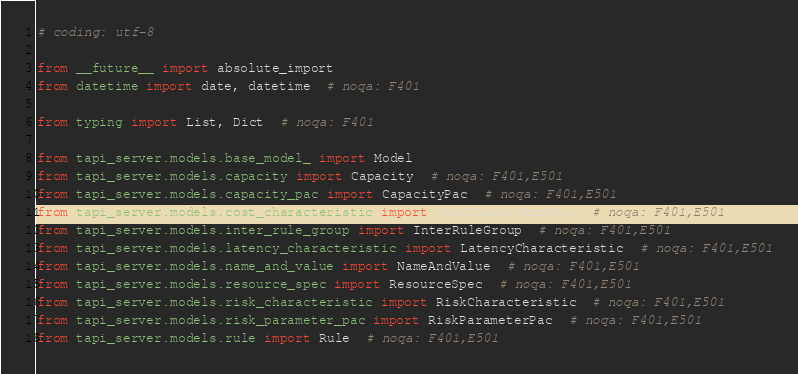Convert code to text. <code><loc_0><loc_0><loc_500><loc_500><_Python_># coding: utf-8

from __future__ import absolute_import
from datetime import date, datetime  # noqa: F401

from typing import List, Dict  # noqa: F401

from tapi_server.models.base_model_ import Model
from tapi_server.models.capacity import Capacity  # noqa: F401,E501
from tapi_server.models.capacity_pac import CapacityPac  # noqa: F401,E501
from tapi_server.models.cost_characteristic import CostCharacteristic  # noqa: F401,E501
from tapi_server.models.inter_rule_group import InterRuleGroup  # noqa: F401,E501
from tapi_server.models.latency_characteristic import LatencyCharacteristic  # noqa: F401,E501
from tapi_server.models.name_and_value import NameAndValue  # noqa: F401,E501
from tapi_server.models.resource_spec import ResourceSpec  # noqa: F401,E501
from tapi_server.models.risk_characteristic import RiskCharacteristic  # noqa: F401,E501
from tapi_server.models.risk_parameter_pac import RiskParameterPac  # noqa: F401,E501
from tapi_server.models.rule import Rule  # noqa: F401,E501</code> 